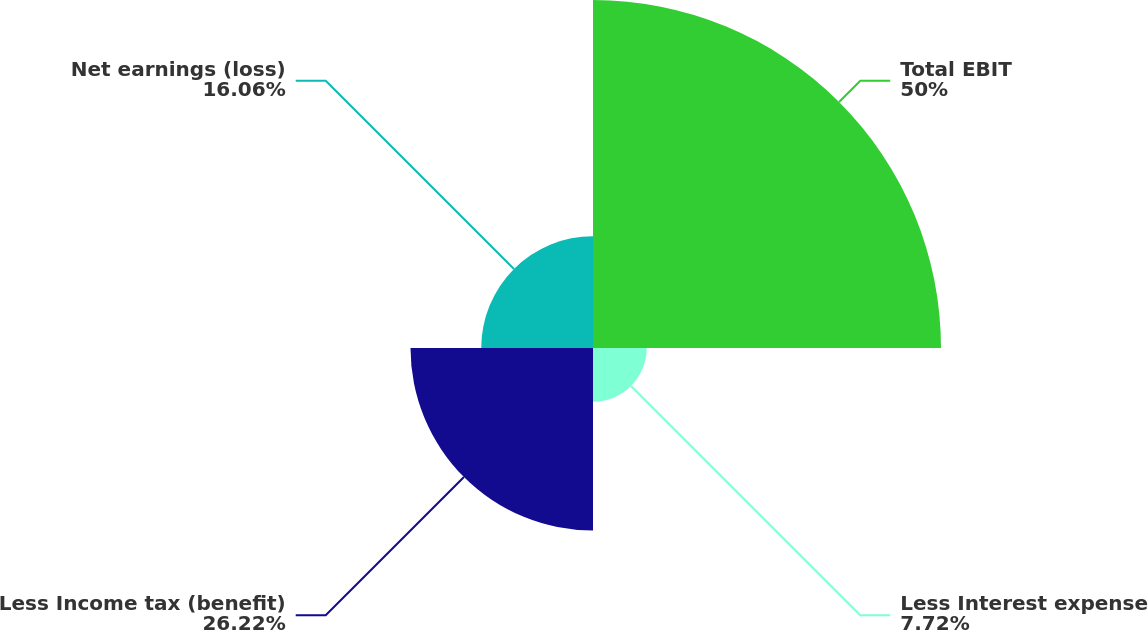<chart> <loc_0><loc_0><loc_500><loc_500><pie_chart><fcel>Total EBIT<fcel>Less Interest expense<fcel>Less Income tax (benefit)<fcel>Net earnings (loss)<nl><fcel>50.0%<fcel>7.72%<fcel>26.22%<fcel>16.06%<nl></chart> 